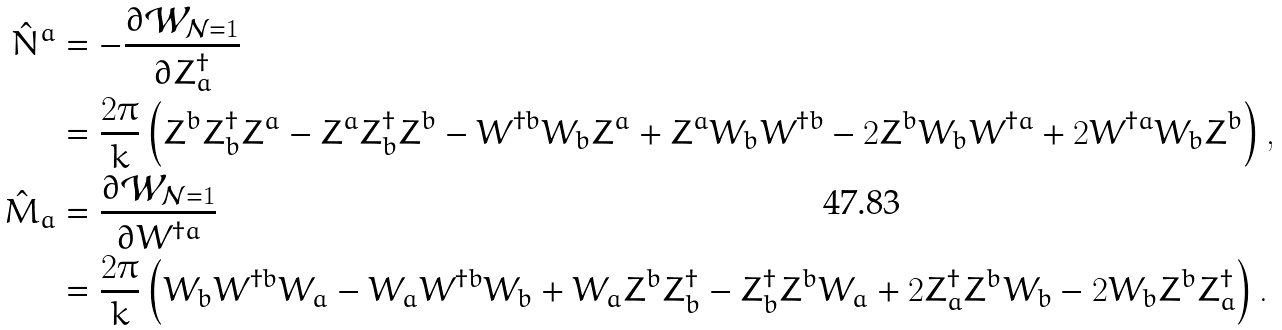Convert formula to latex. <formula><loc_0><loc_0><loc_500><loc_500>\hat { N } ^ { a } & = - \frac { \partial \mathcal { W } _ { \mathcal { N } = 1 } } { \partial Z ^ { \dag } _ { a } } \\ & = \frac { 2 \pi } { k } \left ( Z ^ { b } Z ^ { \dag } _ { b } Z ^ { a } - Z ^ { a } Z ^ { \dag } _ { b } Z ^ { b } - W ^ { \dag b } W _ { b } Z ^ { a } + Z ^ { a } W _ { b } W ^ { \dag b } - 2 Z ^ { b } W _ { b } W ^ { \dag a } + 2 W ^ { \dag a } W _ { b } Z ^ { b } \right ) , \\ \hat { M } _ { a } & = \frac { \partial \mathcal { W } _ { \mathcal { N } = 1 } } { \partial W ^ { \dag a } } \\ & = \frac { 2 \pi } { k } \left ( W _ { b } W ^ { \dag b } W _ { a } - W _ { a } W ^ { \dag b } W _ { b } + W _ { a } Z ^ { b } Z ^ { \dag } _ { b } - Z ^ { \dag } _ { b } Z ^ { b } W _ { a } + 2 Z ^ { \dag } _ { a } Z ^ { b } W _ { b } - 2 W _ { b } Z ^ { b } Z ^ { \dag } _ { a } \right ) .</formula> 